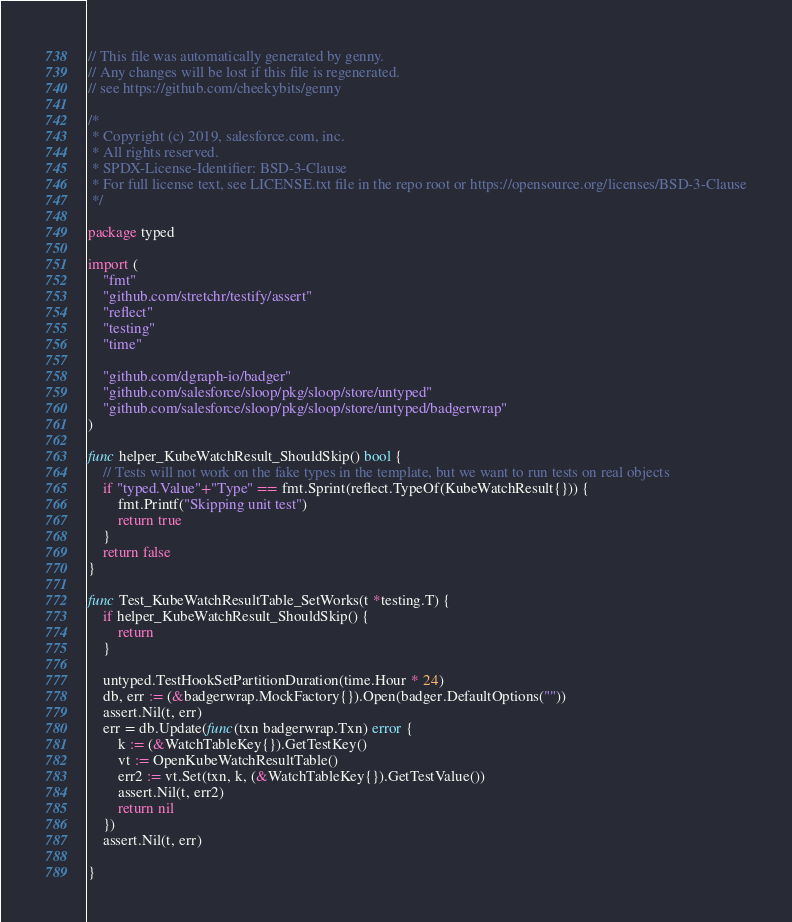Convert code to text. <code><loc_0><loc_0><loc_500><loc_500><_Go_>// This file was automatically generated by genny.
// Any changes will be lost if this file is regenerated.
// see https://github.com/cheekybits/genny

/*
 * Copyright (c) 2019, salesforce.com, inc.
 * All rights reserved.
 * SPDX-License-Identifier: BSD-3-Clause
 * For full license text, see LICENSE.txt file in the repo root or https://opensource.org/licenses/BSD-3-Clause
 */

package typed

import (
	"fmt"
	"github.com/stretchr/testify/assert"
	"reflect"
	"testing"
	"time"

	"github.com/dgraph-io/badger"
	"github.com/salesforce/sloop/pkg/sloop/store/untyped"
	"github.com/salesforce/sloop/pkg/sloop/store/untyped/badgerwrap"
)

func helper_KubeWatchResult_ShouldSkip() bool {
	// Tests will not work on the fake types in the template, but we want to run tests on real objects
	if "typed.Value"+"Type" == fmt.Sprint(reflect.TypeOf(KubeWatchResult{})) {
		fmt.Printf("Skipping unit test")
		return true
	}
	return false
}

func Test_KubeWatchResultTable_SetWorks(t *testing.T) {
	if helper_KubeWatchResult_ShouldSkip() {
		return
	}

	untyped.TestHookSetPartitionDuration(time.Hour * 24)
	db, err := (&badgerwrap.MockFactory{}).Open(badger.DefaultOptions(""))
	assert.Nil(t, err)
	err = db.Update(func(txn badgerwrap.Txn) error {
		k := (&WatchTableKey{}).GetTestKey()
		vt := OpenKubeWatchResultTable()
		err2 := vt.Set(txn, k, (&WatchTableKey{}).GetTestValue())
		assert.Nil(t, err2)
		return nil
	})
	assert.Nil(t, err)

}
</code> 